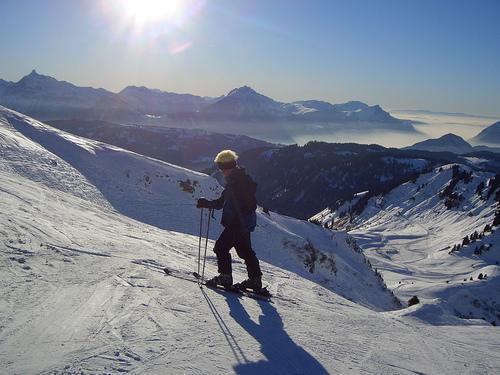How many ski poles does this person have?
Give a very brief answer. 2. How many knives are in the block?
Give a very brief answer. 0. 